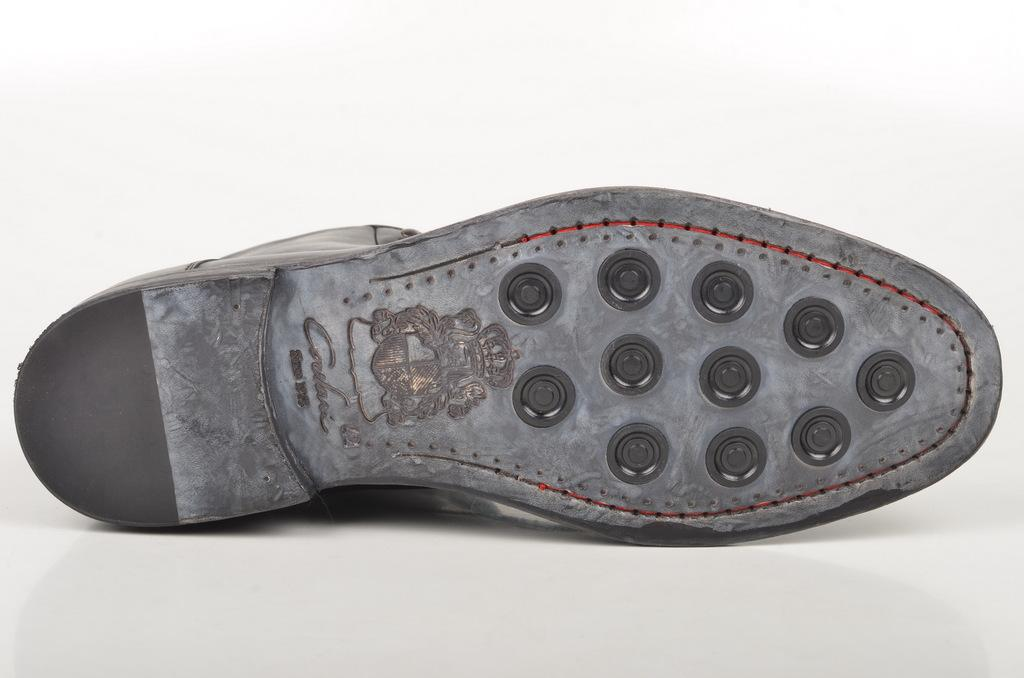What object is the main subject of the image? There is a shoe in the image. What color is the shoe? The shoe is black in color. What color is the background of the image? The background of the image is white. What language is the shoe speaking in the image? Shoes do not speak, so there is no language present in the image. 